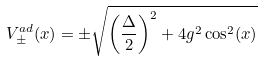Convert formula to latex. <formula><loc_0><loc_0><loc_500><loc_500>V _ { \pm } ^ { a d } ( x ) = \pm \sqrt { \left ( \frac { \Delta } { 2 } \right ) ^ { 2 } + 4 g ^ { 2 } \cos ^ { 2 } ( x ) }</formula> 